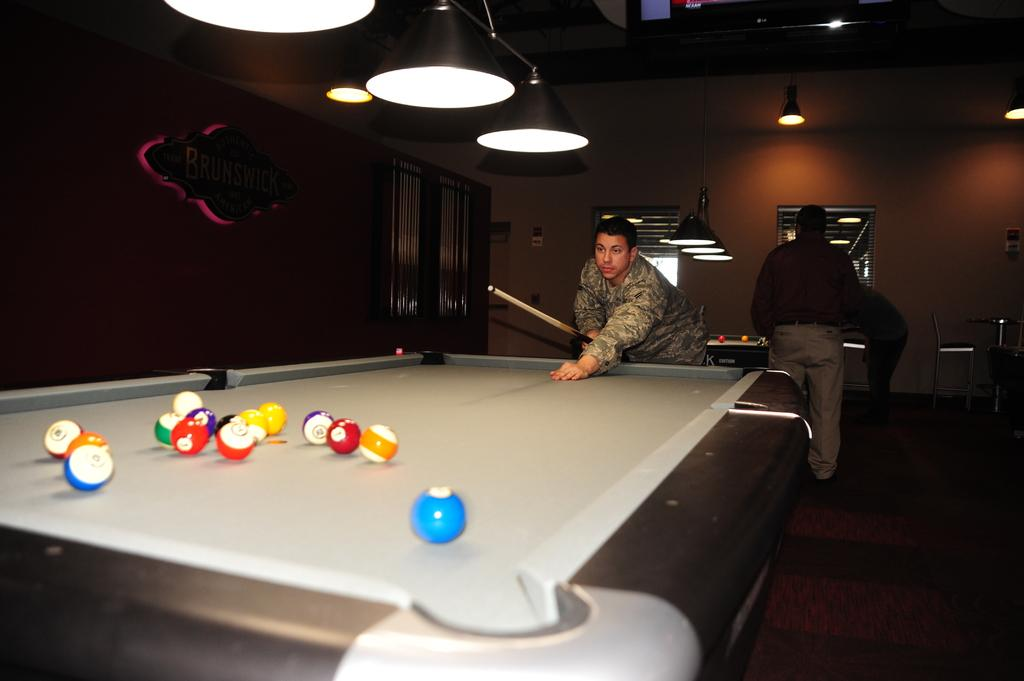What are the people in the image doing? The people in the image are standing. What is the main object in the image? There is a billiard board in the image. What is the man holding in the image? The man is holding a stick, likely a billiard cue. What is on the billiard board? There are balls on the billiard board. What type of comb is the man using to style his hair in the image? There is no comb visible in the image, and the man's hair is not being styled. 